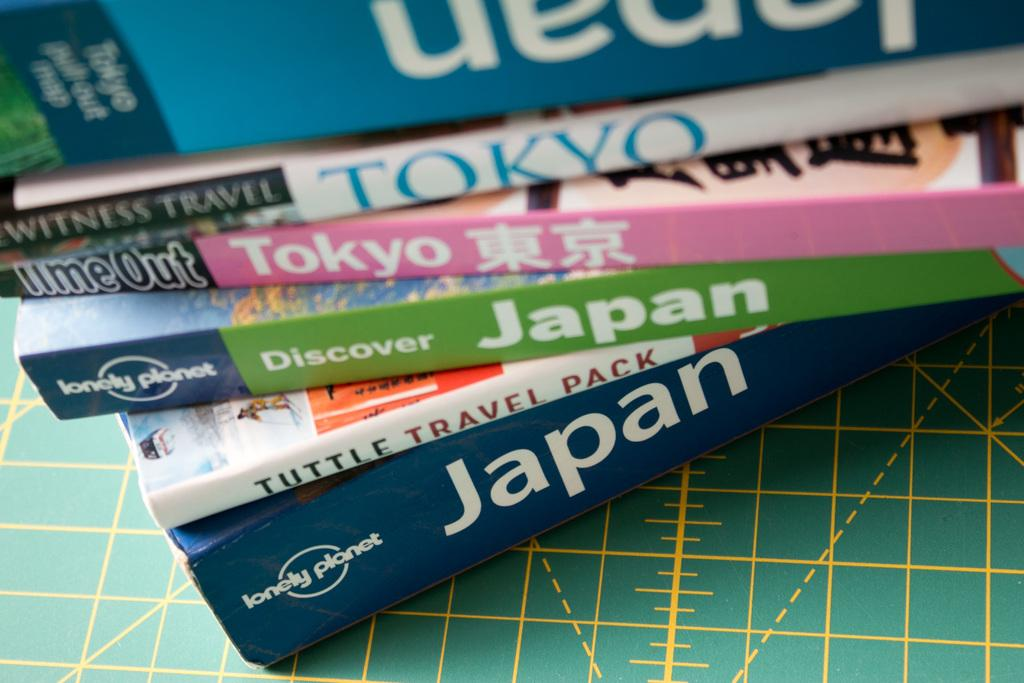<image>
Describe the image concisely. A stack of books with either Japan or Tokyo in the title. 